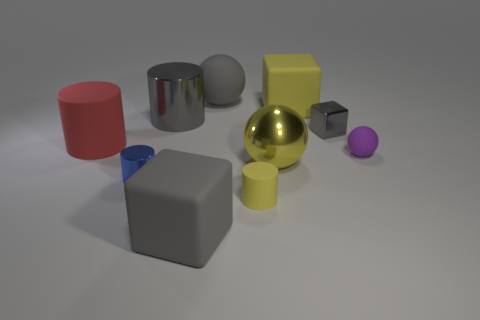Subtract all cubes. How many objects are left? 7 Add 4 tiny yellow cylinders. How many tiny yellow cylinders are left? 5 Add 5 matte blocks. How many matte blocks exist? 7 Subtract 0 cyan balls. How many objects are left? 10 Subtract all blocks. Subtract all yellow matte things. How many objects are left? 5 